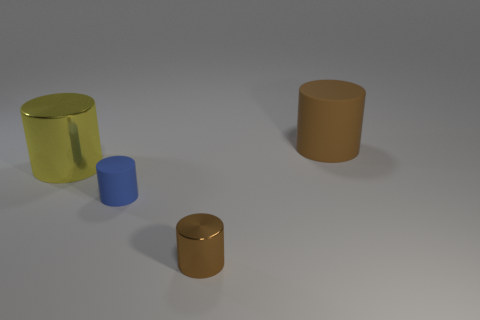Subtract all red cylinders. Subtract all purple blocks. How many cylinders are left? 4 Add 2 large yellow metal cylinders. How many objects exist? 6 Add 1 large brown matte cylinders. How many large brown matte cylinders exist? 2 Subtract 0 red cylinders. How many objects are left? 4 Subtract all small rubber things. Subtract all big blue balls. How many objects are left? 3 Add 2 small blue matte cylinders. How many small blue matte cylinders are left? 3 